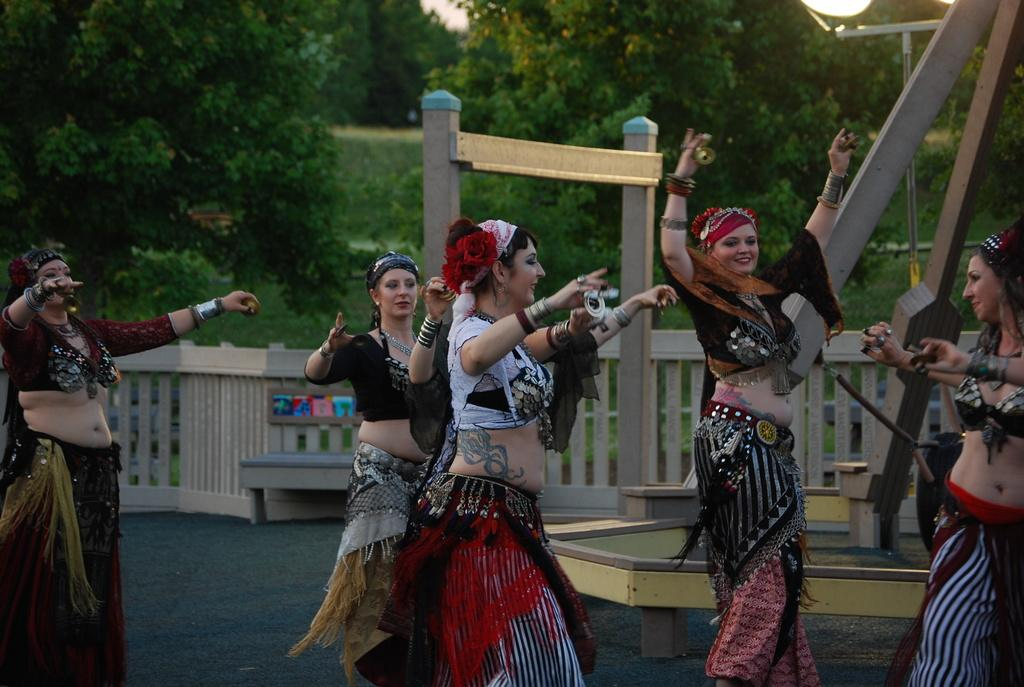How many women are present in the image? There are women in the image, but the exact number is not specified. What are the women wearing? The women are wearing different costumes in the image. What activity are the women engaged in? The women are dancing on the ground in the image. What can be seen in the background of the image? In the background of the image, there is a fence, poles, light poles, grass, and trees. What type of bird can be seen digesting a stew in the image? There is no bird or stew present in the image; it features women dancing in different costumes. 